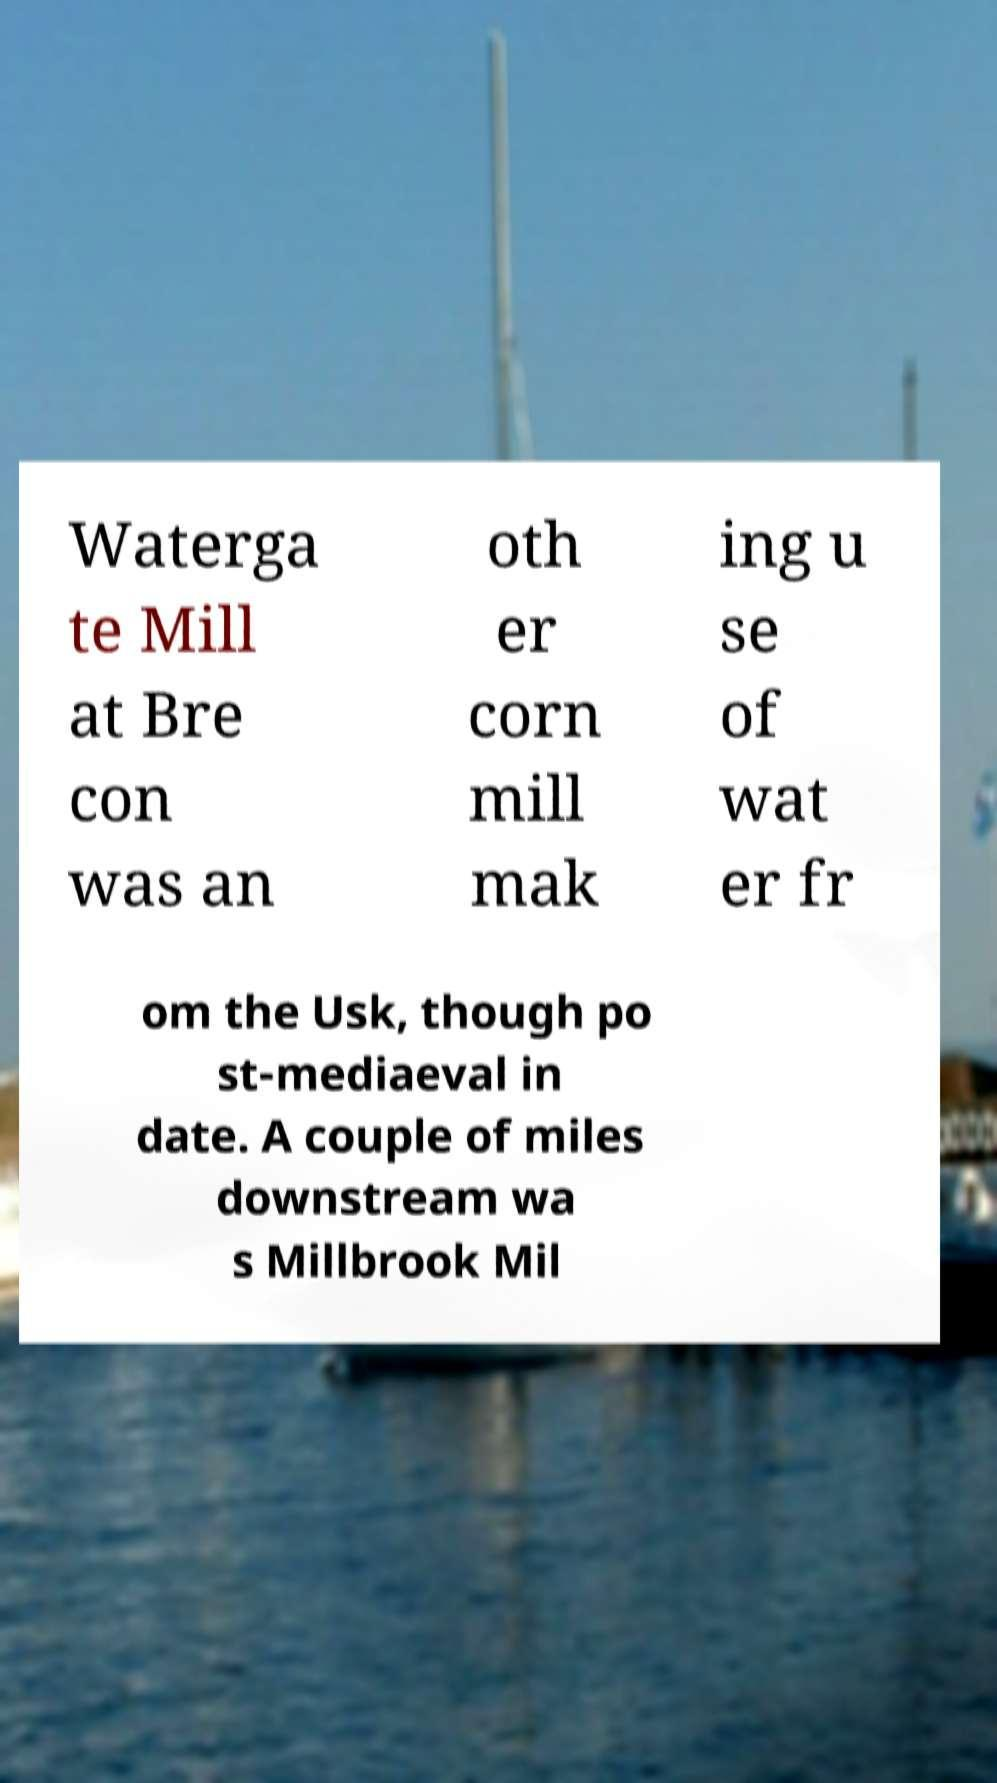Can you accurately transcribe the text from the provided image for me? Waterga te Mill at Bre con was an oth er corn mill mak ing u se of wat er fr om the Usk, though po st-mediaeval in date. A couple of miles downstream wa s Millbrook Mil 